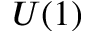Convert formula to latex. <formula><loc_0><loc_0><loc_500><loc_500>U ( 1 )</formula> 